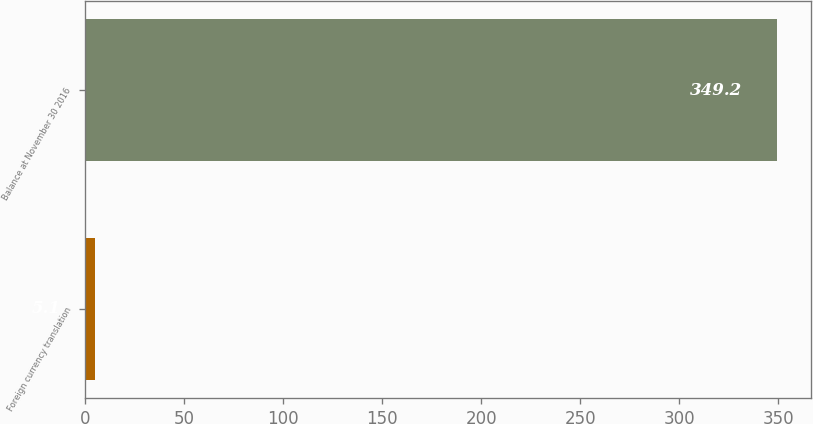<chart> <loc_0><loc_0><loc_500><loc_500><bar_chart><fcel>Foreign currency translation<fcel>Balance at November 30 2016<nl><fcel>5.1<fcel>349.2<nl></chart> 